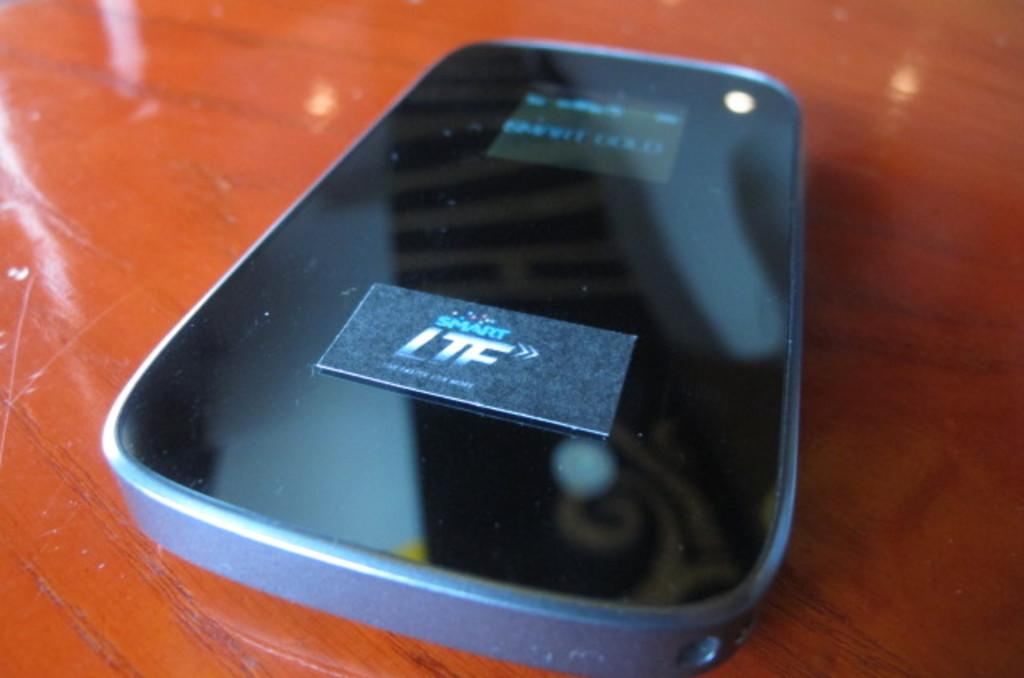<image>
Offer a succinct explanation of the picture presented. Cellphone that has Smart LTE on top of a wooden table. 